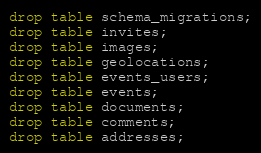<code> <loc_0><loc_0><loc_500><loc_500><_SQL_>drop table schema_migrations;
drop table invites;
drop table images;
drop table geolocations;
drop table events_users;
drop table events;
drop table documents;
drop table comments;
drop table addresses;
</code> 